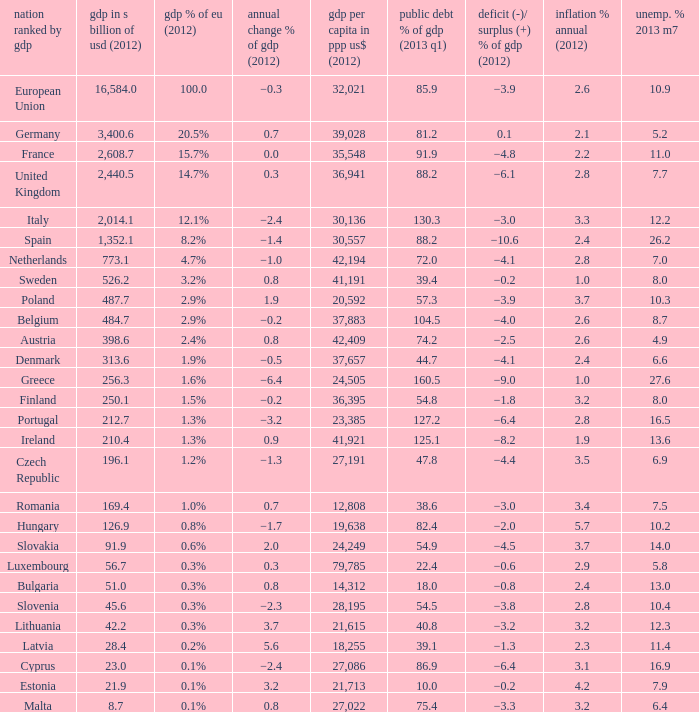What is the average public debt % of GDP in 2013 Q1 of the country with a member slate sorted by GDP of Czech Republic and a GDP per capita in PPP US dollars in 2012 greater than 27,191? None. 